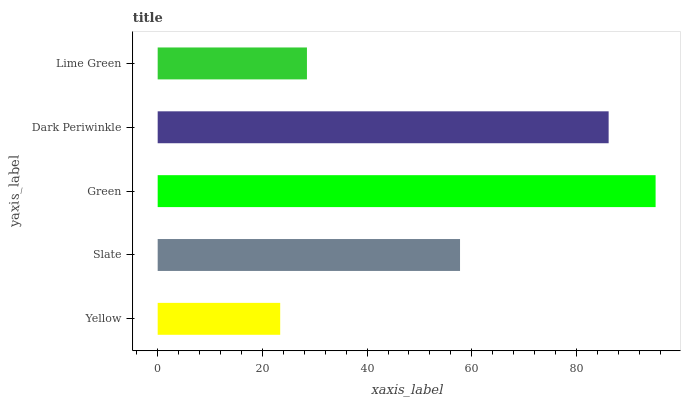Is Yellow the minimum?
Answer yes or no. Yes. Is Green the maximum?
Answer yes or no. Yes. Is Slate the minimum?
Answer yes or no. No. Is Slate the maximum?
Answer yes or no. No. Is Slate greater than Yellow?
Answer yes or no. Yes. Is Yellow less than Slate?
Answer yes or no. Yes. Is Yellow greater than Slate?
Answer yes or no. No. Is Slate less than Yellow?
Answer yes or no. No. Is Slate the high median?
Answer yes or no. Yes. Is Slate the low median?
Answer yes or no. Yes. Is Yellow the high median?
Answer yes or no. No. Is Green the low median?
Answer yes or no. No. 